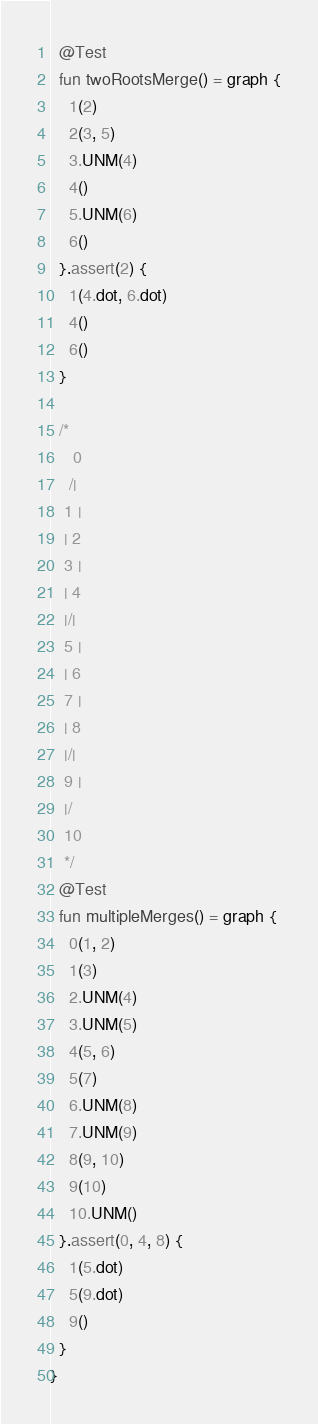<code> <loc_0><loc_0><loc_500><loc_500><_Kotlin_>  @Test
  fun twoRootsMerge() = graph {
    1(2)
    2(3, 5)
    3.UNM(4)
    4()
    5.UNM(6)
    6()
  }.assert(2) {
    1(4.dot, 6.dot)
    4()
    6()
  }

  /*
     0
    /|
   1 |
   | 2
   3 |
   | 4
   |/|
   5 |
   | 6
   7 |
   | 8
   |/|
   9 |
   |/
   10
   */
  @Test
  fun multipleMerges() = graph {
    0(1, 2)
    1(3)
    2.UNM(4)
    3.UNM(5)
    4(5, 6)
    5(7)
    6.UNM(8)
    7.UNM(9)
    8(9, 10)
    9(10)
    10.UNM()
  }.assert(0, 4, 8) {
    1(5.dot)
    5(9.dot)
    9()
  }
}</code> 